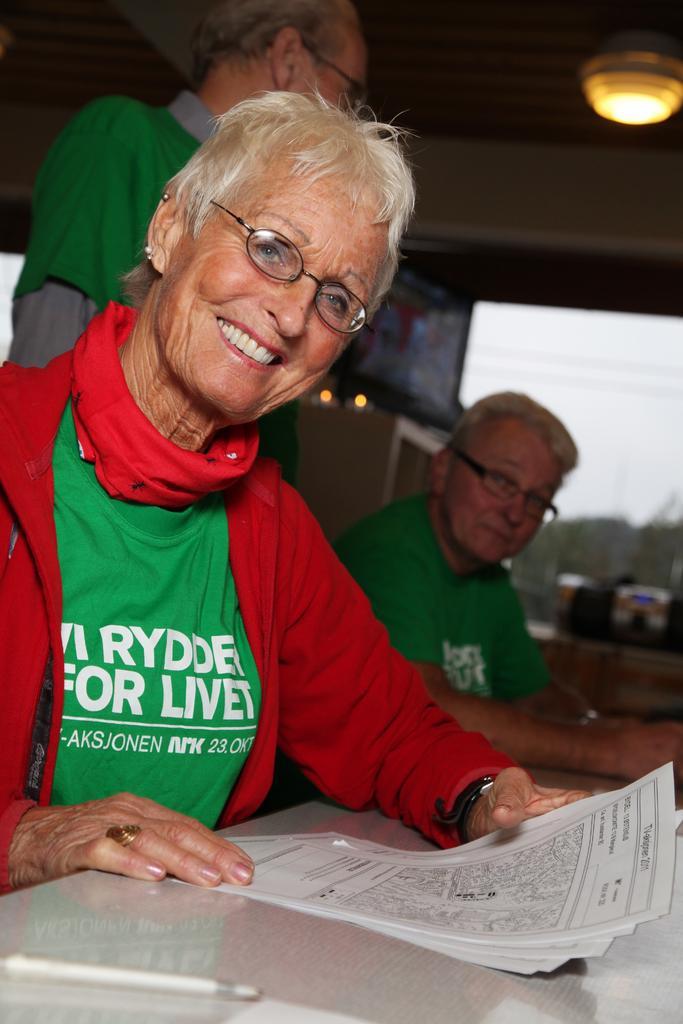Could you give a brief overview of what you see in this image? This picture is clicked inside the room. In the foreground we can see a woman wearing green color T-shirt, smiling and sitting and holding a paper and we can see the text and some pictures on the paper and we can see a pen is placed on the top of the table. In the background, we can see the sky, a person sitting and a person standing and we can see the roof, lights and some other objects. 